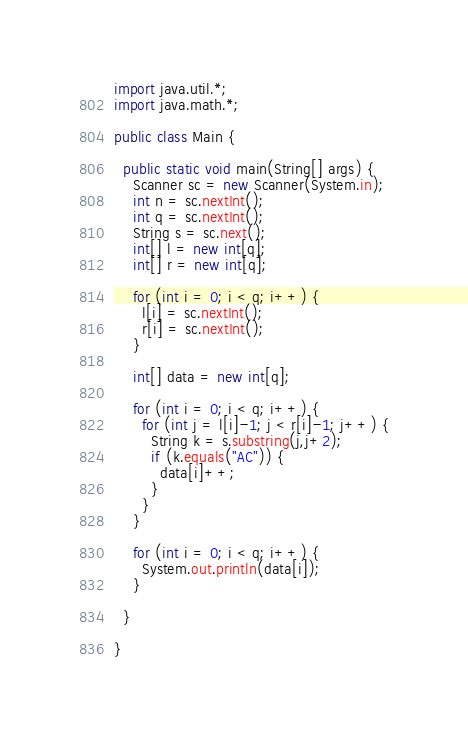Convert code to text. <code><loc_0><loc_0><loc_500><loc_500><_Java_>import java.util.*;
import java.math.*;

public class Main {

  public static void main(String[] args) {
    Scanner sc = new Scanner(System.in);
    int n = sc.nextInt();
    int q = sc.nextInt();
    String s = sc.next();
    int[] l = new int[q];
    int[] r = new int[q];

    for (int i = 0; i < q; i++) {
      l[i] = sc.nextInt();
      r[i] = sc.nextInt();
    }

    int[] data = new int[q];

    for (int i = 0; i < q; i++) {
      for (int j = l[i]-1; j < r[i]-1; j++) {
        String k = s.substring(j,j+2);
        if (k.equals("AC")) {
          data[i]++;
        }
      }
    }

    for (int i = 0; i < q; i++) {
      System.out.println(data[i]);
    }

  }

}
</code> 